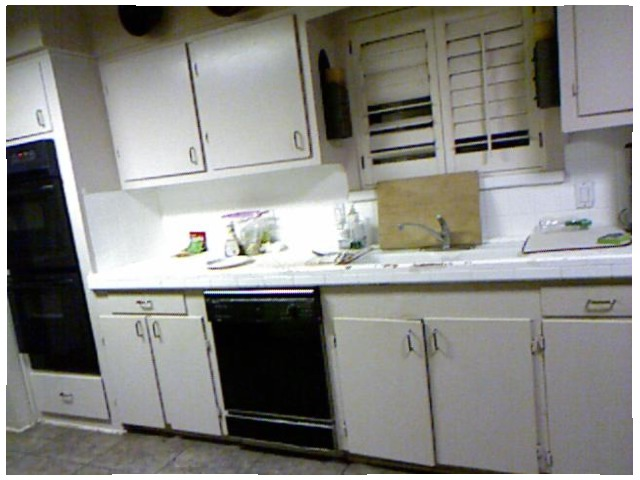<image>
Can you confirm if the cupboard is above the table? Yes. The cupboard is positioned above the table in the vertical space, higher up in the scene. 